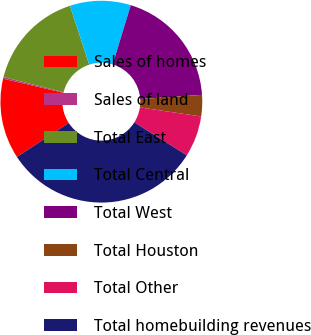Convert chart. <chart><loc_0><loc_0><loc_500><loc_500><pie_chart><fcel>Sales of homes<fcel>Sales of land<fcel>Total East<fcel>Total Central<fcel>Total West<fcel>Total Houston<fcel>Total Other<fcel>Total homebuilding revenues<nl><fcel>12.89%<fcel>0.26%<fcel>16.05%<fcel>9.74%<fcel>19.21%<fcel>3.42%<fcel>6.58%<fcel>31.84%<nl></chart> 